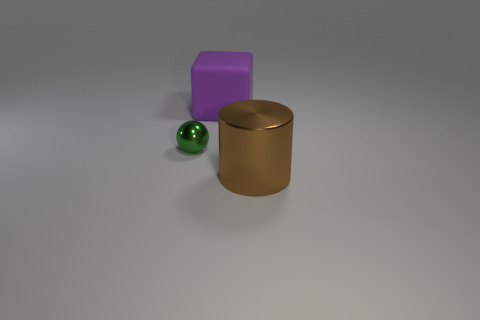Is there anything else that has the same size as the ball?
Ensure brevity in your answer.  No. Are there any other things that have the same shape as the tiny metal object?
Offer a very short reply. No. There is a object that is left of the big brown cylinder and in front of the matte thing; what shape is it?
Provide a short and direct response. Sphere. What shape is the tiny thing that is made of the same material as the brown cylinder?
Offer a terse response. Sphere. Is there a big cyan block?
Offer a very short reply. No. There is a thing that is behind the tiny thing; is there a small green sphere that is behind it?
Make the answer very short. No. Is the number of brown cylinders greater than the number of blue balls?
Your answer should be compact. Yes. What color is the thing that is both to the left of the brown metal thing and in front of the purple object?
Offer a very short reply. Green. What number of other objects are the same material as the cube?
Your response must be concise. 0. Are there fewer tiny balls than gray things?
Offer a very short reply. No. 